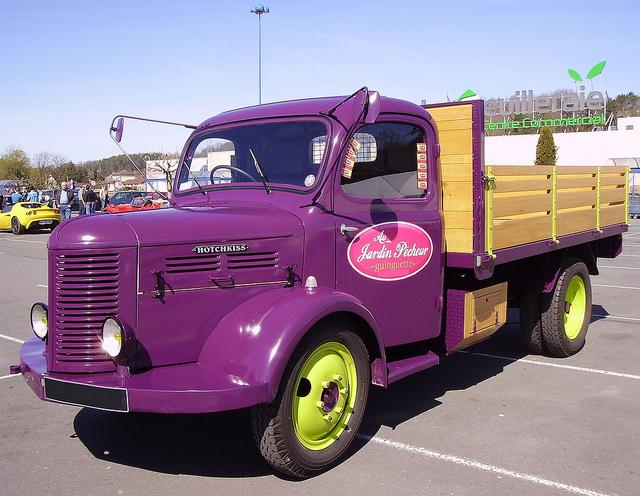Which television character is the same color as this truck? Please explain your reasoning. barney. The purple truck and barney are the same color. 